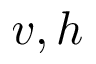Convert formula to latex. <formula><loc_0><loc_0><loc_500><loc_500>v , h</formula> 